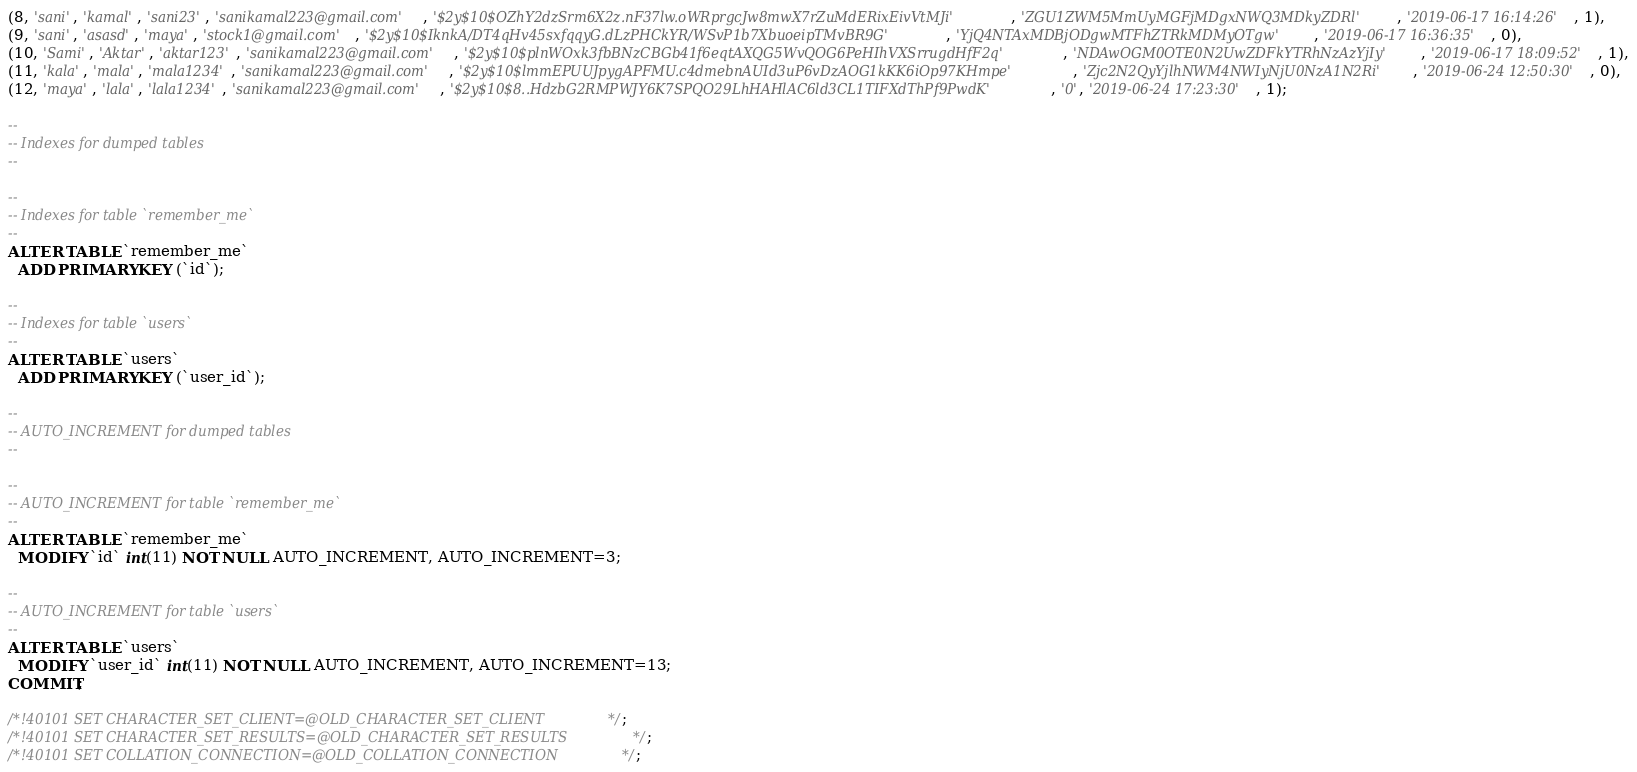<code> <loc_0><loc_0><loc_500><loc_500><_SQL_>(8, 'sani', 'kamal', 'sani23', 'sanikamal223@gmail.com', '$2y$10$OZhY2dzSrm6X2z.nF37lw.oWRprgcJw8mwX7rZuMdERixEivVtMJi', 'ZGU1ZWM5MmUyMGFjMDgxNWQ3MDkyZDRl', '2019-06-17 16:14:26', 1),
(9, 'sani', 'asasd', 'maya', 'stock1@gmail.com', '$2y$10$IknkA/DT4qHv45sxfqqyG.dLzPHCkYR/WSvP1b7XbuoeipTMvBR9G', 'YjQ4NTAxMDBjODgwMTFhZTRkMDMyOTgw', '2019-06-17 16:36:35', 0),
(10, 'Sami', 'Aktar', 'aktar123', 'sanikamal223@gmail.com', '$2y$10$plnWOxk3fbBNzCBGb41f6eqtAXQG5WvQOG6PeHIhVXSrrugdHfF2q', 'NDAwOGM0OTE0N2UwZDFkYTRhNzAzYjIy', '2019-06-17 18:09:52', 1),
(11, 'kala', 'mala', 'mala1234', 'sanikamal223@gmail.com', '$2y$10$lmmEPUUJpygAPFMU.c4dmebnAUId3uP6vDzAOG1kKK6iOp97KHmpe', 'Zjc2N2QyYjlhNWM4NWIyNjU0NzA1N2Ri', '2019-06-24 12:50:30', 0),
(12, 'maya', 'lala', 'lala1234', 'sanikamal223@gmail.com', '$2y$10$8..HdzbG2RMPWJY6K7SPQO29LhHAHlAC6ld3CL1TIFXdThPf9PwdK', '0', '2019-06-24 17:23:30', 1);

--
-- Indexes for dumped tables
--

--
-- Indexes for table `remember_me`
--
ALTER TABLE `remember_me`
  ADD PRIMARY KEY (`id`);

--
-- Indexes for table `users`
--
ALTER TABLE `users`
  ADD PRIMARY KEY (`user_id`);

--
-- AUTO_INCREMENT for dumped tables
--

--
-- AUTO_INCREMENT for table `remember_me`
--
ALTER TABLE `remember_me`
  MODIFY `id` int(11) NOT NULL AUTO_INCREMENT, AUTO_INCREMENT=3;

--
-- AUTO_INCREMENT for table `users`
--
ALTER TABLE `users`
  MODIFY `user_id` int(11) NOT NULL AUTO_INCREMENT, AUTO_INCREMENT=13;
COMMIT;

/*!40101 SET CHARACTER_SET_CLIENT=@OLD_CHARACTER_SET_CLIENT */;
/*!40101 SET CHARACTER_SET_RESULTS=@OLD_CHARACTER_SET_RESULTS */;
/*!40101 SET COLLATION_CONNECTION=@OLD_COLLATION_CONNECTION */;
</code> 